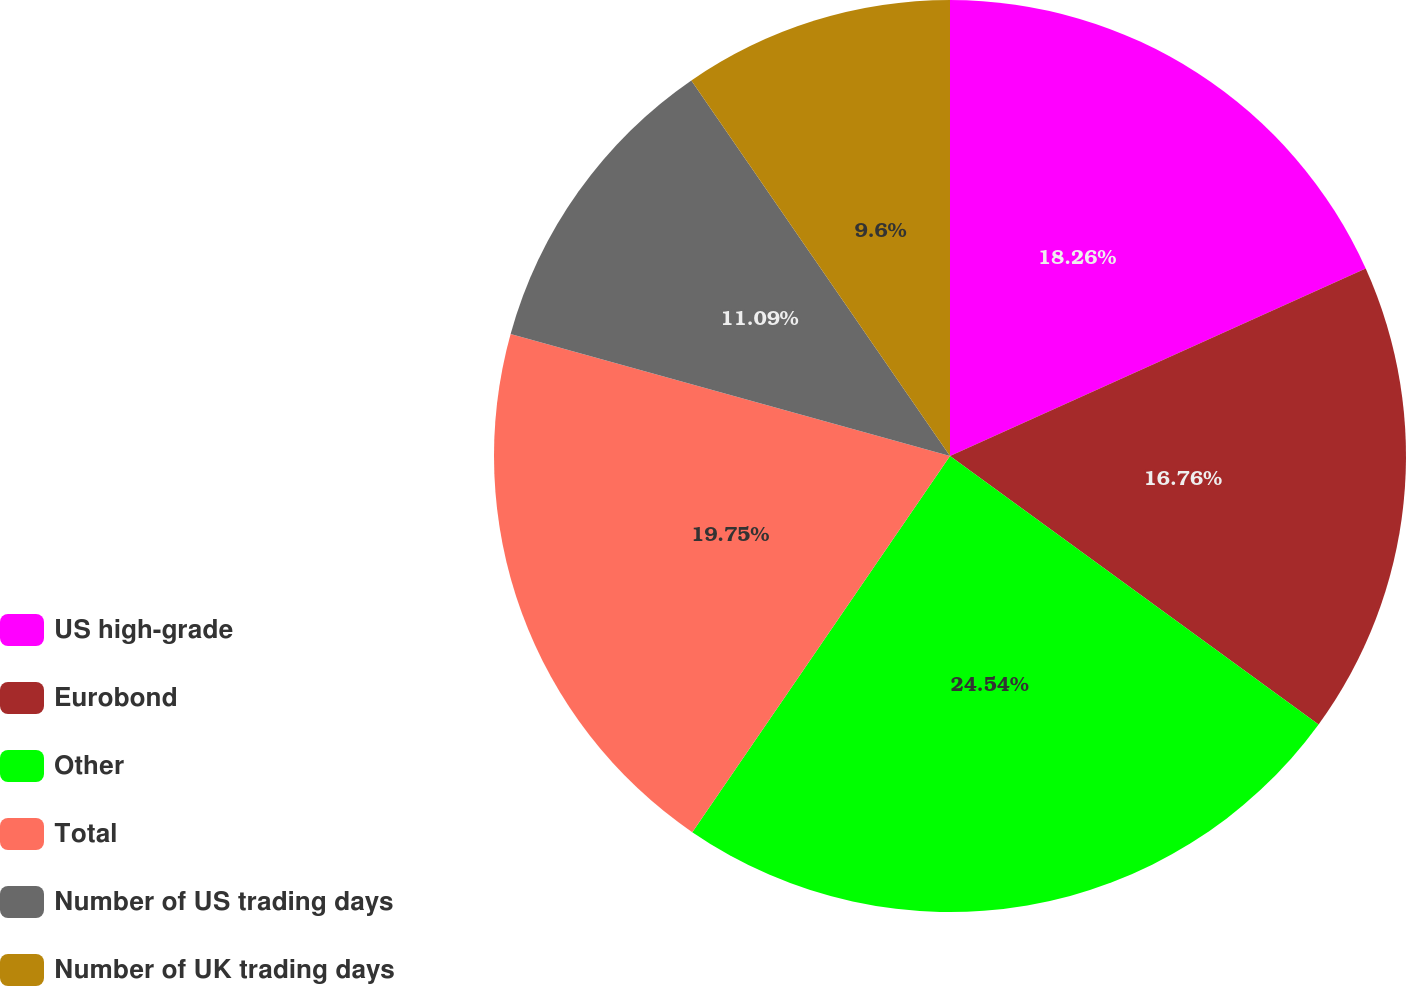Convert chart to OTSL. <chart><loc_0><loc_0><loc_500><loc_500><pie_chart><fcel>US high-grade<fcel>Eurobond<fcel>Other<fcel>Total<fcel>Number of US trading days<fcel>Number of UK trading days<nl><fcel>18.26%<fcel>16.76%<fcel>24.54%<fcel>19.75%<fcel>11.09%<fcel>9.6%<nl></chart> 